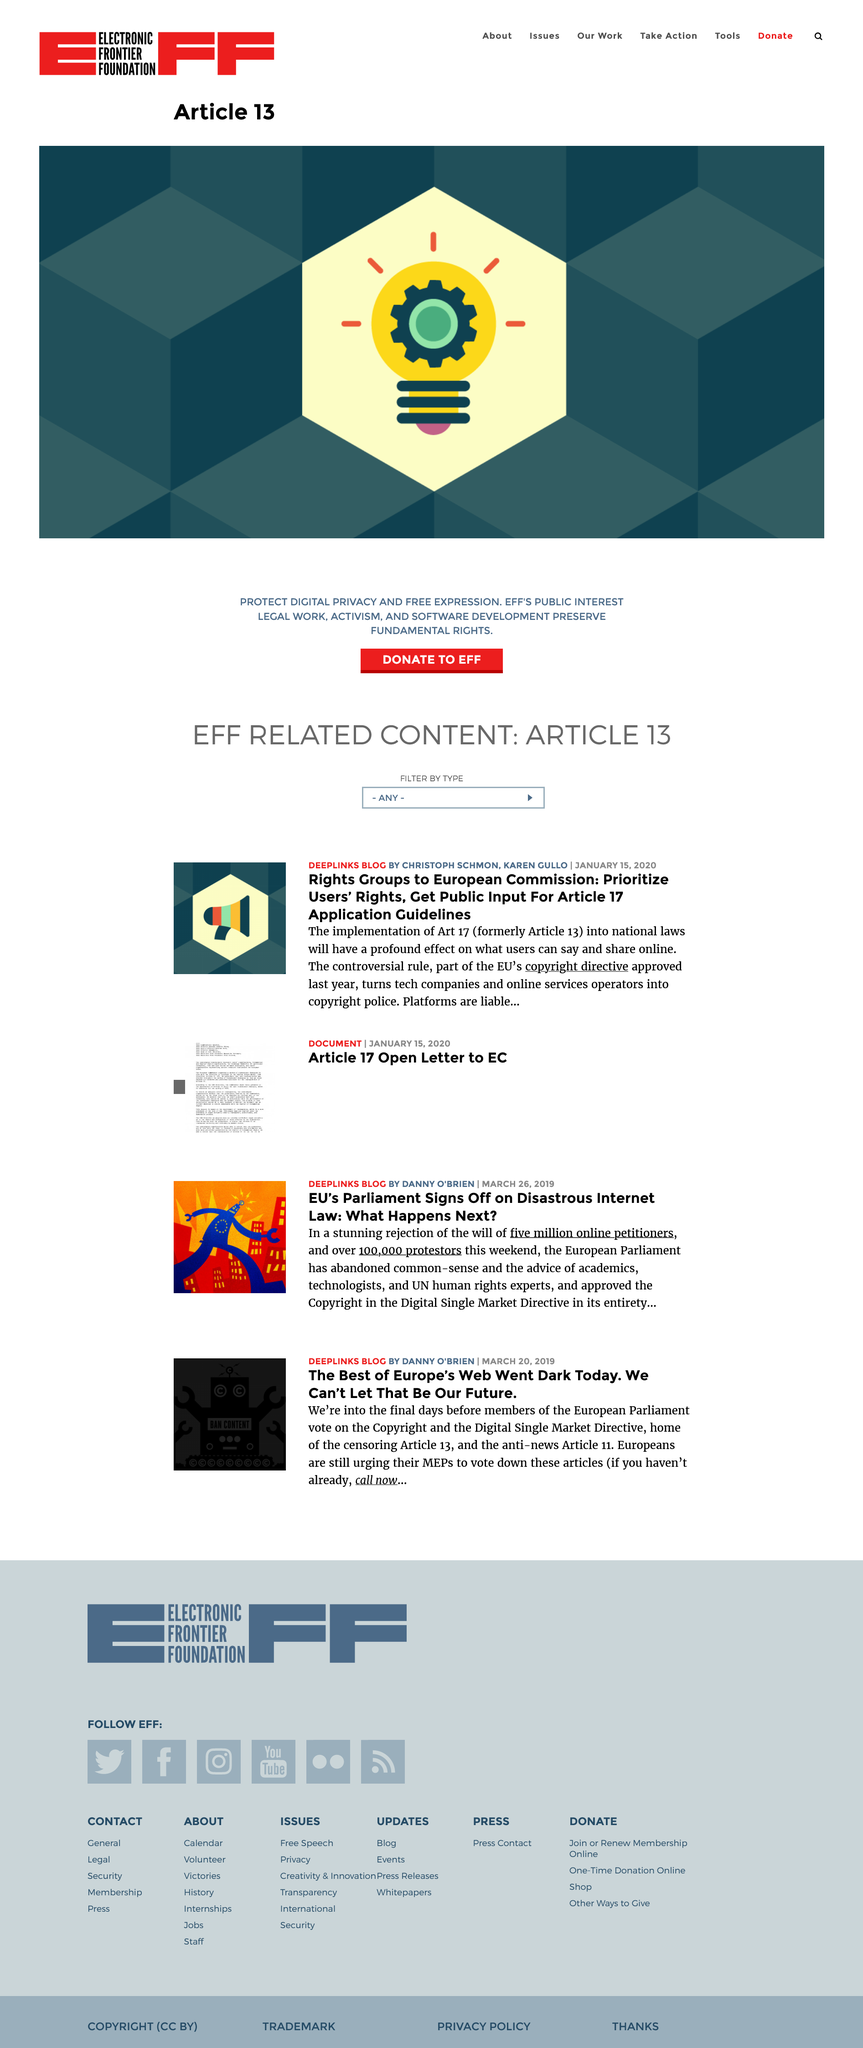Outline some significant characteristics in this image. The article on the European Union's parliament signing off on a disastrous internet law was published on March 26, 2019. Danny O'Brien wrote the article about the EU Parliament's approval of a disastrous internet law. There were five million online petitioners. 